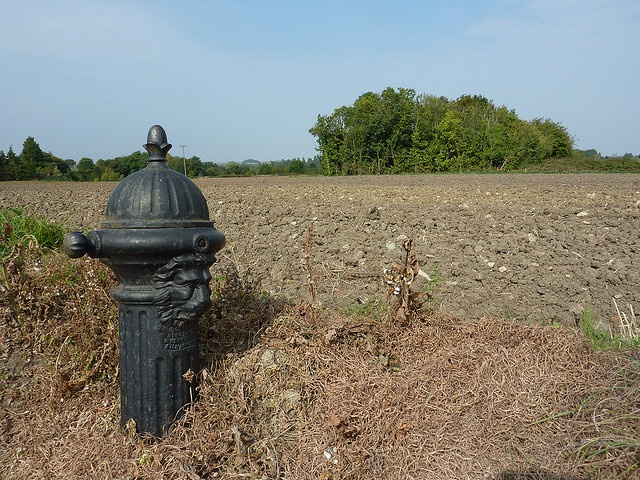Describe the objects in this image and their specific colors. I can see a fire hydrant in lightblue, black, gray, and purple tones in this image. 